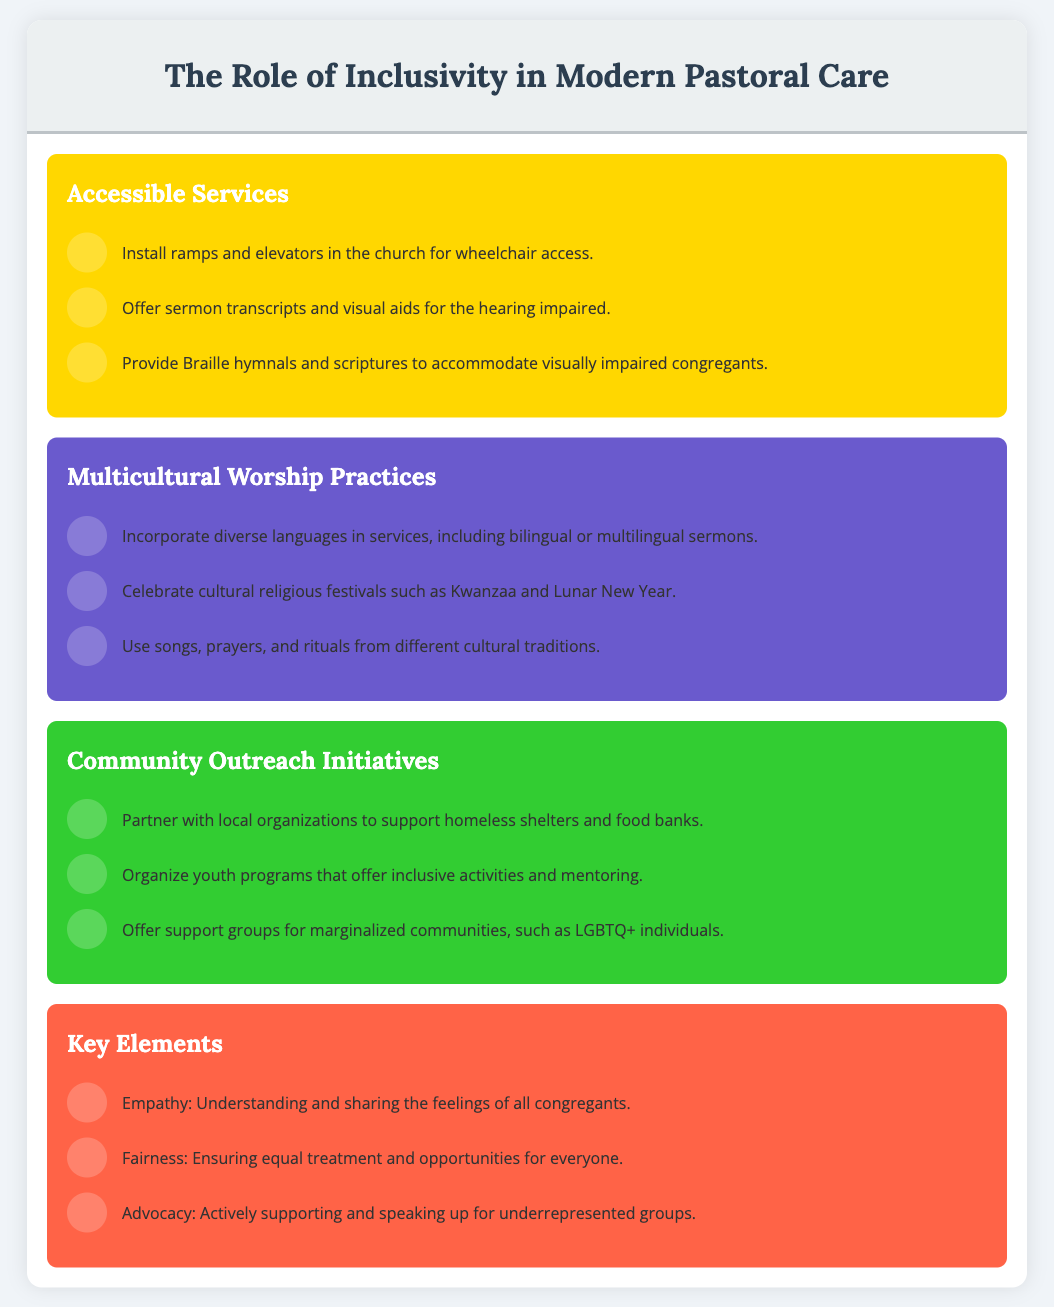What is the purpose of including ramps in the church? The ramps are installed for wheelchair access.
Answer: Wheelchair access Which cultural religious festivals are celebrated according to the infographic? The infographic mentions Kwanzaa and Lunar New Year.
Answer: Kwanzaa and Lunar New Year What is one way to support marginalized communities? Support groups can be offered for these communities.
Answer: Support groups How many key elements are listed in the infographic? There are three key elements highlighted in the document.
Answer: Three What color represents Community Outreach Initiatives? The background color for this section is green.
Answer: Green 